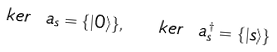Convert formula to latex. <formula><loc_0><loc_0><loc_500><loc_500>k e r \ a _ { s } = \{ | 0 \rangle \} , \ \ k e r \ a _ { s } ^ { \dagger } = \{ | s \rangle \}</formula> 